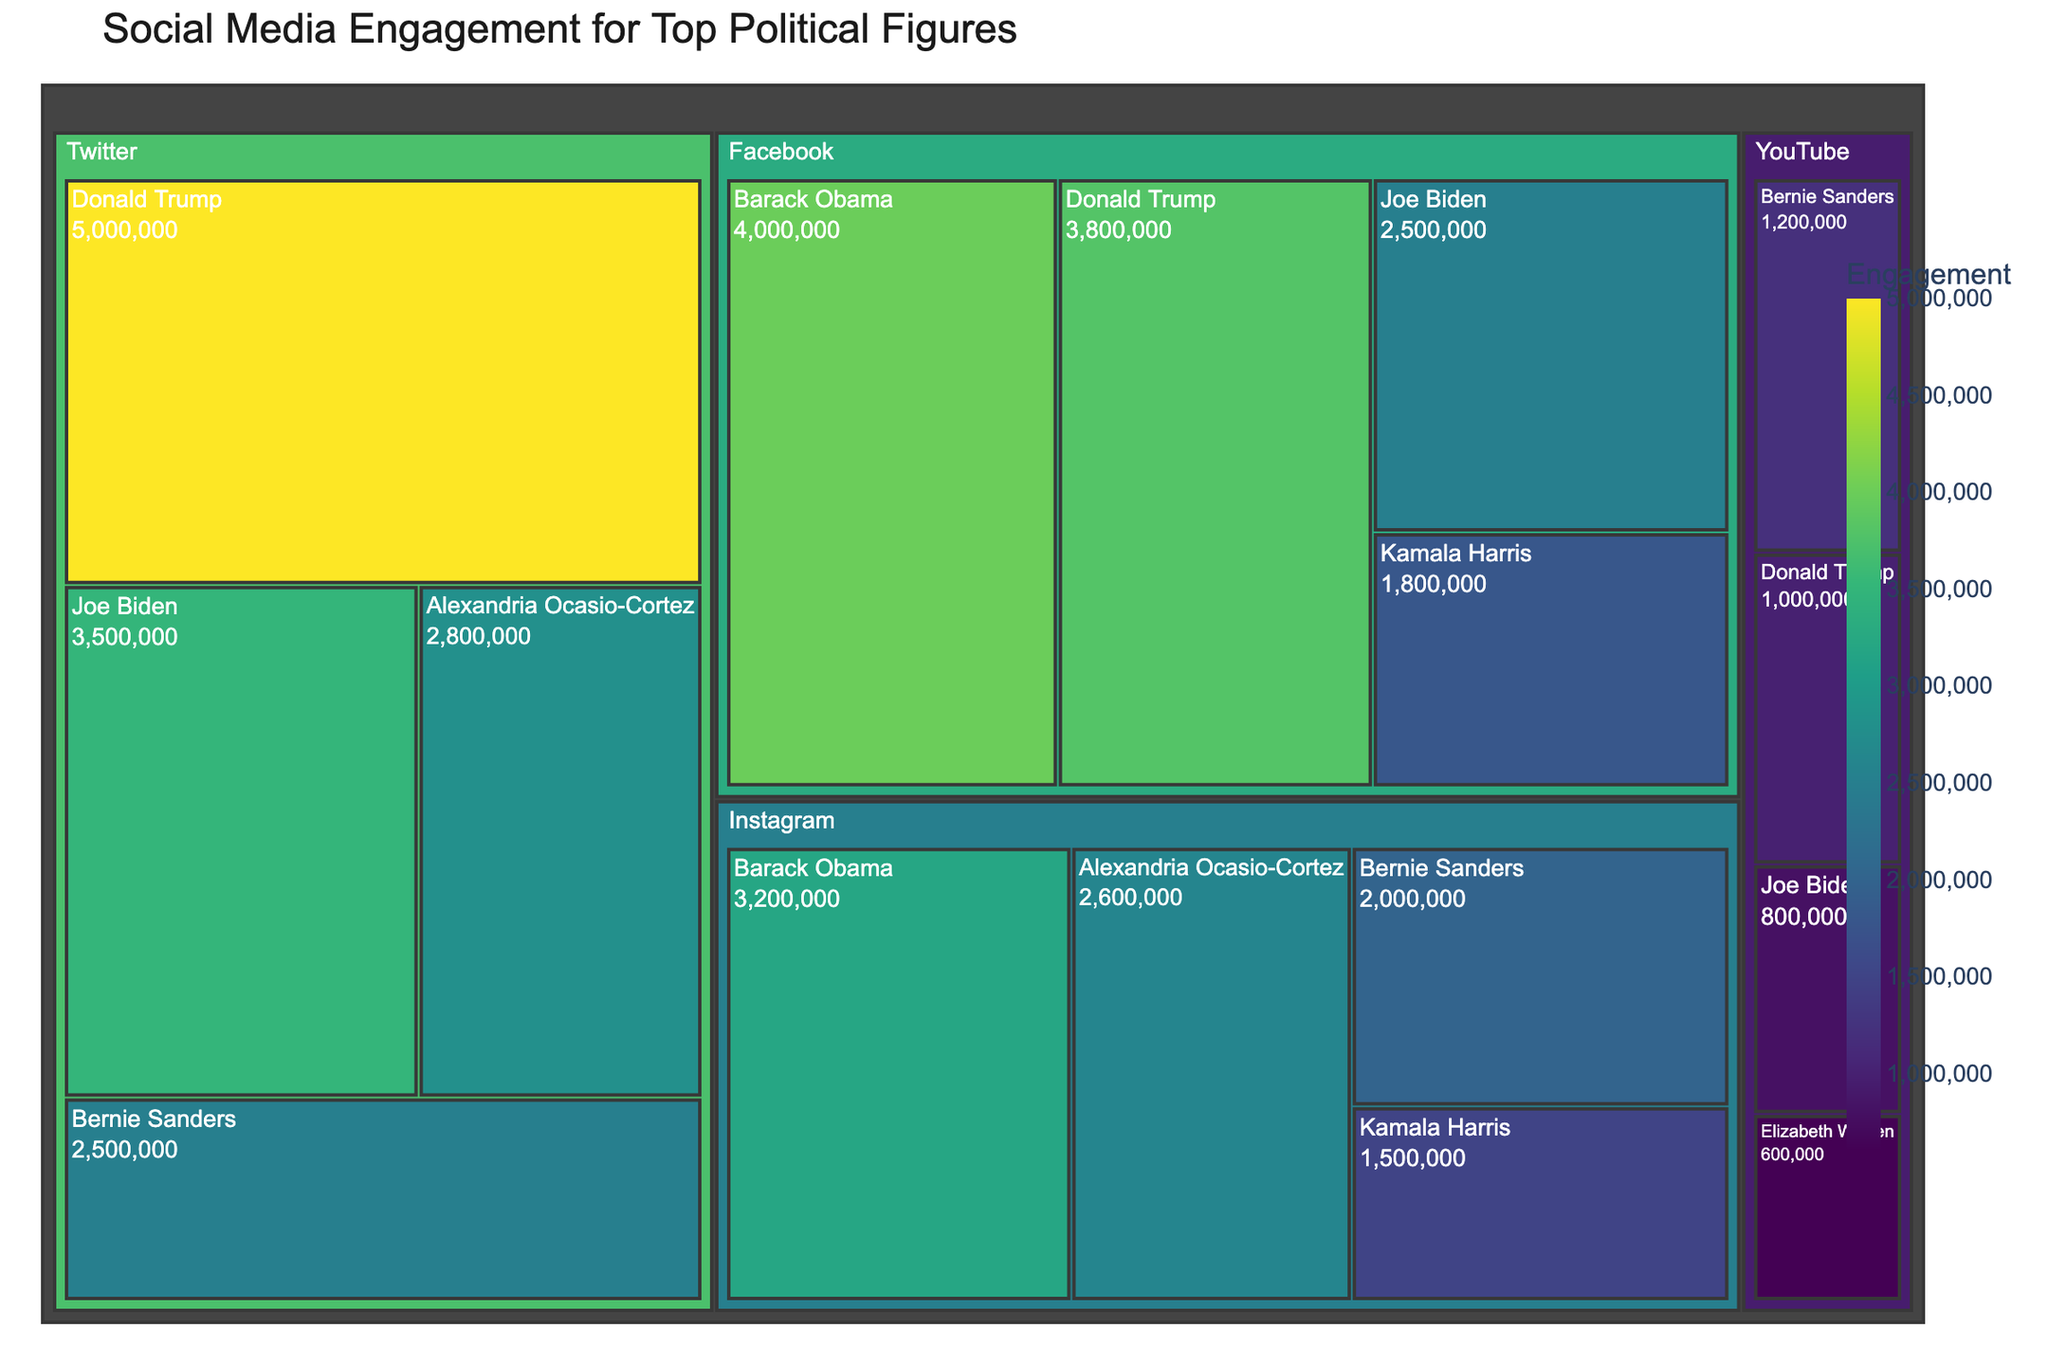What's the title of the treemap? The title of the treemap is usually displayed at the top center of the plot for easy visibility. In this figure, it's explicitly defined in the code.
Answer: Social Media Engagement for Top Political Figures Which politician has the highest engagement on Twitter? Locate the section of the treemap corresponding to the Twitter platform. The politician with the largest area/block in that section will have the highest engagement.
Answer: Donald Trump How does Barack Obama's engagement on Instagram compare to his engagement on Facebook? Find Barack Obama's segments in both the Instagram and Facebook sections of the treemap. Compare the engagement values indicated on these segments.
Answer: Higher on Facebook What's the total engagement of Bernie Sanders across all platforms? Identify all the blocks representing Bernie Sanders on the treemap (on YouTube, Instagram, and Twitter) and sum their engagement values: 1,200,000 (YouTube) + 2,000,000 (Instagram) + 2,500,000 (Twitter).
Answer: 5,700,000 Which platform has the most engagement for Joe Biden? Locate the segments for Joe Biden on each platform section. Compare their engagement values to determine which is the largest.
Answer: Twitter Who has the least engagement on YouTube? Within the YouTube section of the treemap, identify the smallest segment representing a politician.
Answer: Elizabeth Warren What's the combined engagement on Instagram for all listed politicians? Sum the engagement values of all politicians in the Instagram section: 3,200,000 (Barack Obama) + 2,600,000 (Alexandria Ocasio-Cortez) + 2,000,000 (Bernie Sanders) + 1,500,000 (Kamala Harris).
Answer: 9,300,000 How does Kamala Harris's engagement on Instagram compare to her engagement on Facebook? Locate Kamala Harris's segments on both the Instagram and Facebook sections. Compare the relative sizes and the actual engagement values.
Answer: Higher on Facebook Which politician has engagement data on the most platforms? Determine which politician appears in the most platform sections of the treemap. Observe the distribution of segments for each politician.
Answer: Bernie Sanders How do the engagement values of Donald Trump and Joe Biden on Facebook compare to each other? Find the segments for Donald Trump and Joe Biden in the Facebook section. Compare their engagement values directly.
Answer: Donald Trump has higher 